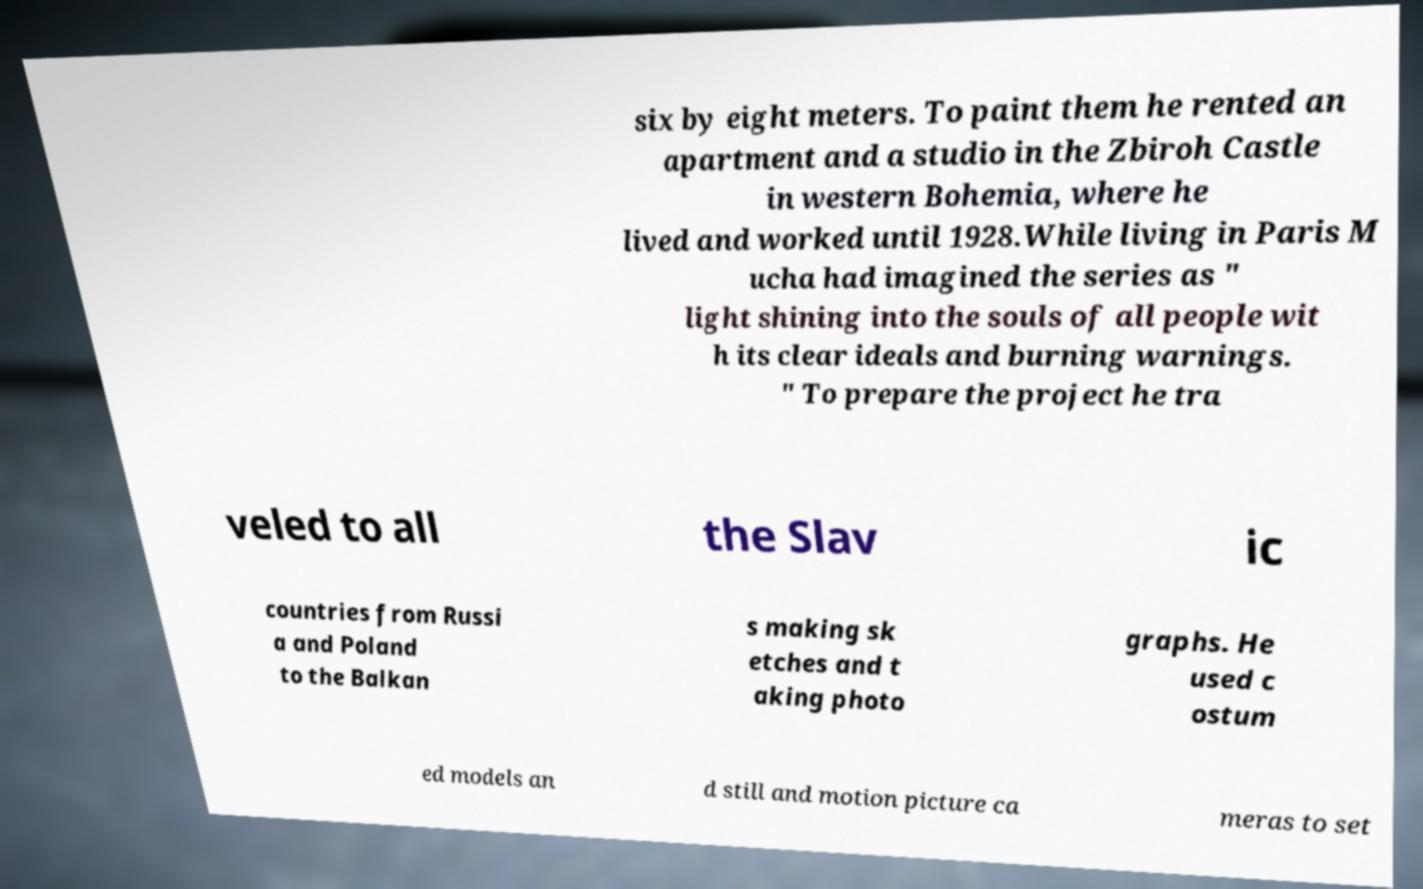Can you accurately transcribe the text from the provided image for me? six by eight meters. To paint them he rented an apartment and a studio in the Zbiroh Castle in western Bohemia, where he lived and worked until 1928.While living in Paris M ucha had imagined the series as " light shining into the souls of all people wit h its clear ideals and burning warnings. " To prepare the project he tra veled to all the Slav ic countries from Russi a and Poland to the Balkan s making sk etches and t aking photo graphs. He used c ostum ed models an d still and motion picture ca meras to set 